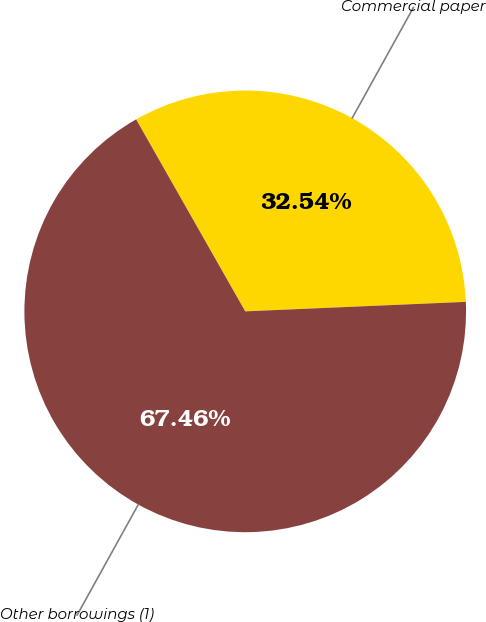Convert chart. <chart><loc_0><loc_0><loc_500><loc_500><pie_chart><fcel>Commercial paper<fcel>Other borrowings (1)<nl><fcel>32.54%<fcel>67.46%<nl></chart> 